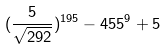<formula> <loc_0><loc_0><loc_500><loc_500>( \frac { 5 } { \sqrt { 2 9 2 } } ) ^ { 1 9 5 } - 4 5 5 ^ { 9 } + 5</formula> 